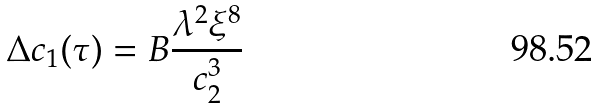<formula> <loc_0><loc_0><loc_500><loc_500>\Delta c _ { 1 } ( \tau ) = B \frac { \lambda ^ { 2 } \xi ^ { 8 } } { c _ { 2 } ^ { 3 } }</formula> 